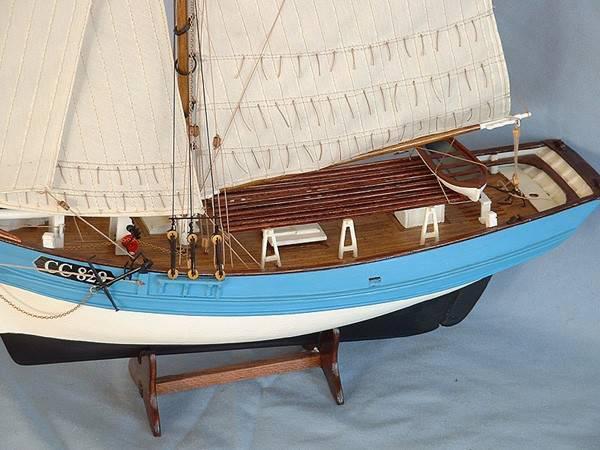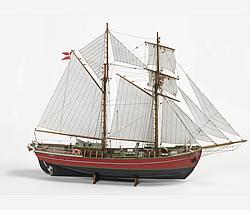The first image is the image on the left, the second image is the image on the right. Examine the images to the left and right. Is the description "The boat in one of the images has exactly 6 sails" accurate? Answer yes or no. No. 